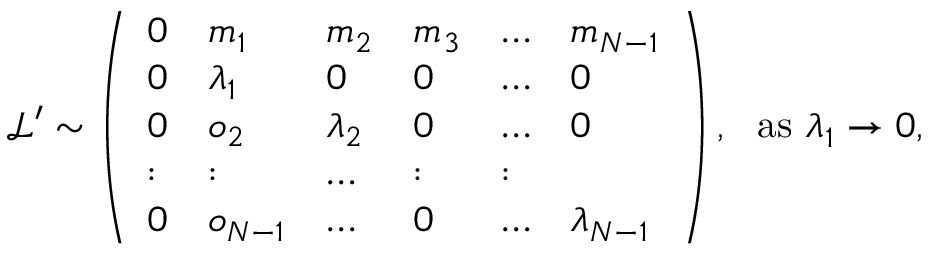<formula> <loc_0><loc_0><loc_500><loc_500>\begin{array} { r } { \, \mathcal { L } ^ { \prime } \sim \left ( \begin{array} { l l l l l l } { 0 } & { m _ { 1 } } & { m _ { 2 } } & { m _ { 3 } } & { \dots } & { m _ { N - 1 } } \\ { 0 } & { \lambda _ { 1 } } & { 0 } & { 0 } & { \dots } & { 0 } \\ { 0 } & { o _ { 2 } } & { \lambda _ { 2 } } & { 0 } & { \dots } & { 0 } \\ { \colon } & { \colon } & { \dots } & { \colon } & { \colon } \\ { 0 } & { o _ { N - 1 } } & { \dots } & { 0 } & { \dots } & { \lambda _ { N - 1 } } \end{array} \right ) , a s \lambda _ { 1 } \rightarrow 0 , } \end{array}</formula> 